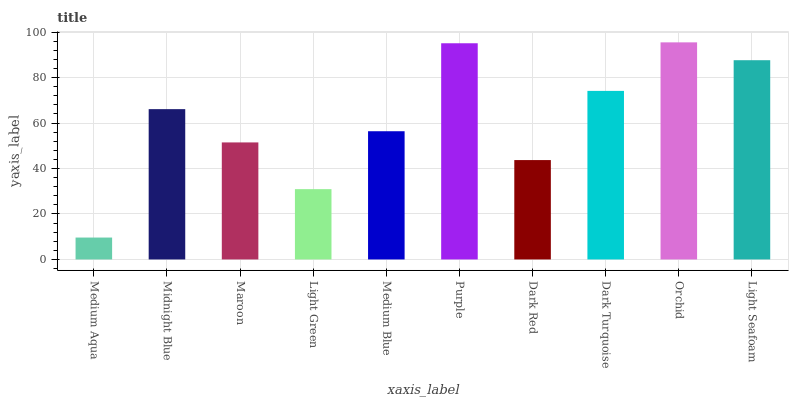Is Medium Aqua the minimum?
Answer yes or no. Yes. Is Orchid the maximum?
Answer yes or no. Yes. Is Midnight Blue the minimum?
Answer yes or no. No. Is Midnight Blue the maximum?
Answer yes or no. No. Is Midnight Blue greater than Medium Aqua?
Answer yes or no. Yes. Is Medium Aqua less than Midnight Blue?
Answer yes or no. Yes. Is Medium Aqua greater than Midnight Blue?
Answer yes or no. No. Is Midnight Blue less than Medium Aqua?
Answer yes or no. No. Is Midnight Blue the high median?
Answer yes or no. Yes. Is Medium Blue the low median?
Answer yes or no. Yes. Is Dark Turquoise the high median?
Answer yes or no. No. Is Light Green the low median?
Answer yes or no. No. 